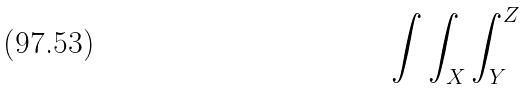<formula> <loc_0><loc_0><loc_500><loc_500>\int \int _ { X } \int _ { Y } ^ { Z }</formula> 